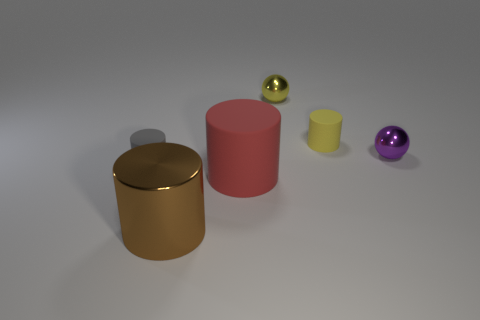If the small purple sphere were to roll towards one of the objects, which direction would it go? If the small purple sphere were to move, it would likely roll towards the right side of the image where the yellow cylinder and golden cylinder are, assuming the surface is level. From the perspective of the image, it doesn't seem to be on an incline or slope that would determine a specific direction of movement. 